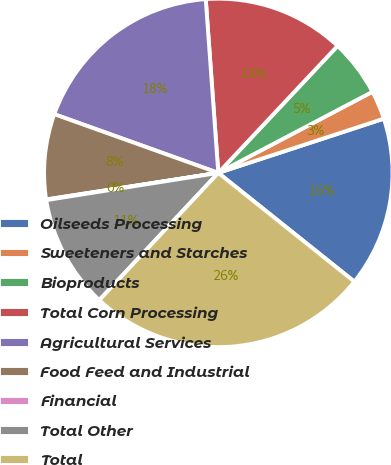Convert chart to OTSL. <chart><loc_0><loc_0><loc_500><loc_500><pie_chart><fcel>Oilseeds Processing<fcel>Sweeteners and Starches<fcel>Bioproducts<fcel>Total Corn Processing<fcel>Agricultural Services<fcel>Food Feed and Industrial<fcel>Financial<fcel>Total Other<fcel>Total<nl><fcel>15.77%<fcel>2.67%<fcel>5.29%<fcel>13.15%<fcel>18.38%<fcel>7.91%<fcel>0.06%<fcel>10.53%<fcel>26.24%<nl></chart> 